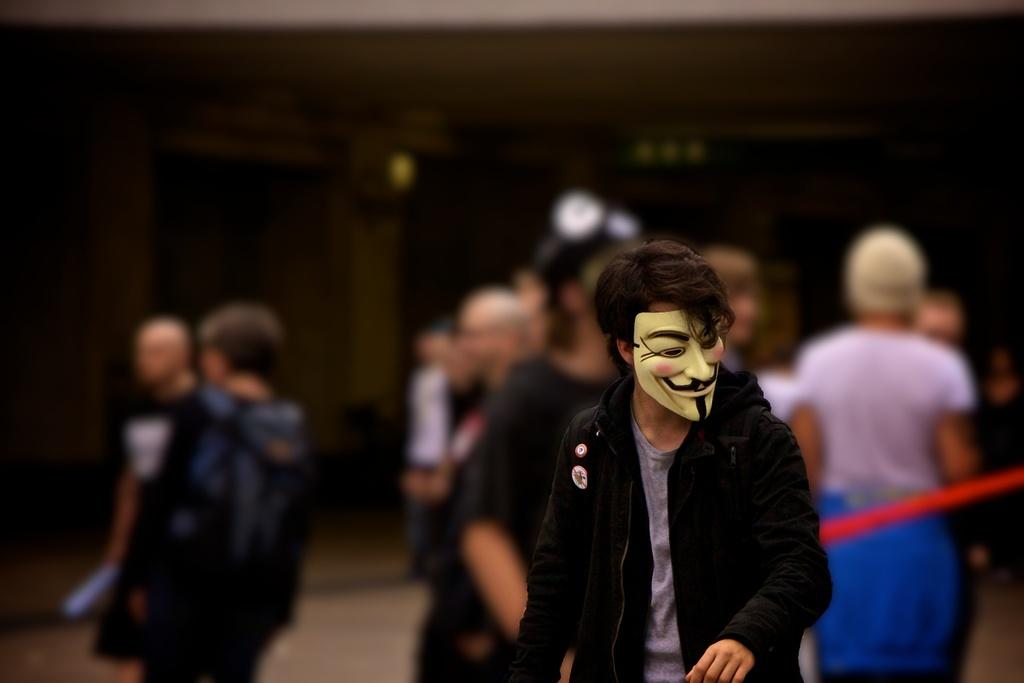What is the person in the image wearing on their face? There is a person wearing a mask in the image. What is the appearance of the background in the image? The background of the image is blurred. Can you describe the presence of other individuals in the image? There are people visible in the image. What type of sponge is being used to clean the eyes of the person in the image? There is no sponge or cleaning activity involving eyes present in the image. 